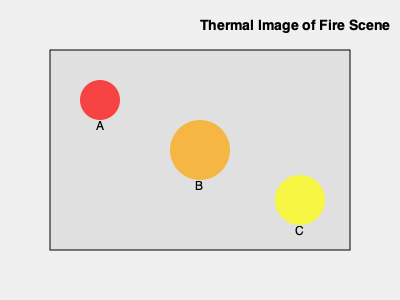Given the thermal image of a fire scene above, which hotspot should be prioritized for immediate attention based on its temperature and size? Assume that the color red indicates the highest temperature, followed by orange, and then yellow. Calculate the area of each hotspot and explain your reasoning. To determine which hotspot should be prioritized, we need to consider both temperature and size. Let's analyze each hotspot:

1. Calculate the areas of each hotspot:
   - Hotspot A (red): $A_A = \pi r^2 = \pi (20)^2 = 1,256.64$ sq units
   - Hotspot B (orange): $A_B = \pi r^2 = \pi (30)^2 = 2,827.43$ sq units
   - Hotspot C (yellow): $A_C = \pi r^2 = \pi (25)^2 = 1,963.50$ sq units

2. Consider the temperature:
   Red > Orange > Yellow

3. Analyze each hotspot:
   - Hotspot A: Highest temperature but smallest area
   - Hotspot B: Medium temperature but largest area
   - Hotspot C: Lowest temperature and medium area

4. Prioritization:
   While Hotspot A has the highest temperature, Hotspot B has a significantly larger area and is still at a high temperature (orange). The combination of its large size and high temperature makes it the most critical threat in the fire scene.

Therefore, Hotspot B should be prioritized for immediate attention as it represents the largest potential for fire spread and intensity.
Answer: Hotspot B 